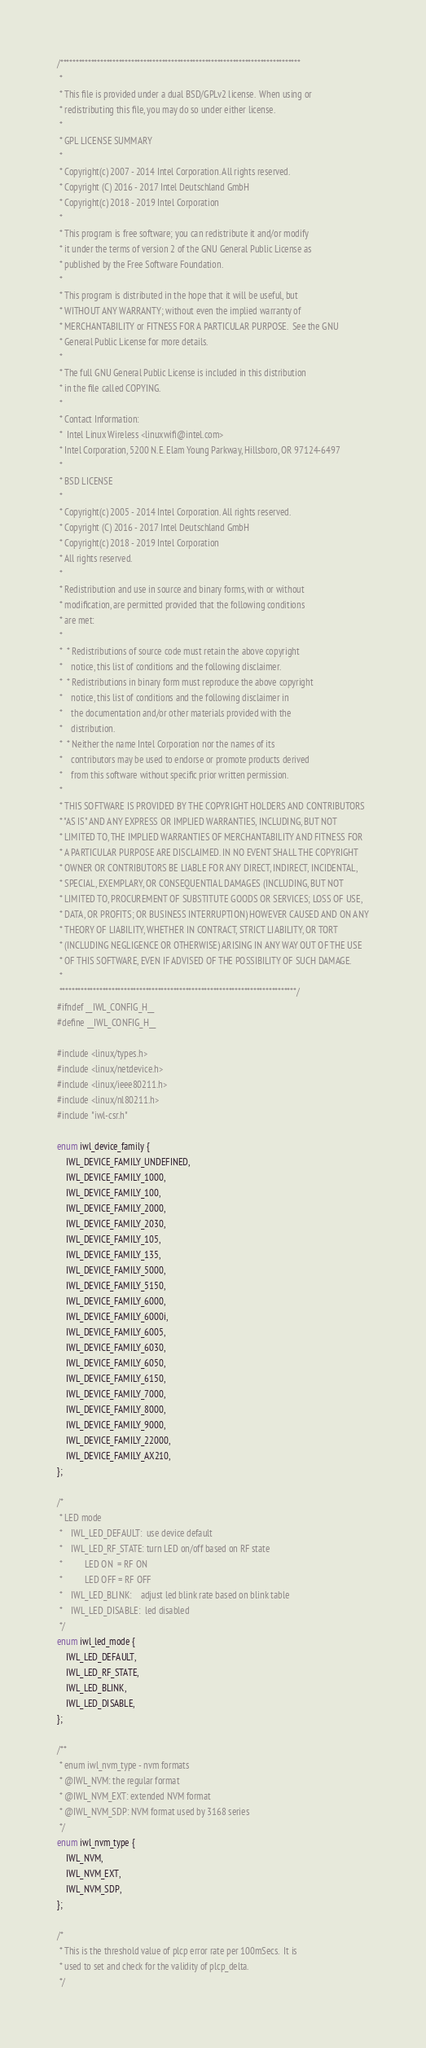Convert code to text. <code><loc_0><loc_0><loc_500><loc_500><_C_>/******************************************************************************
 *
 * This file is provided under a dual BSD/GPLv2 license.  When using or
 * redistributing this file, you may do so under either license.
 *
 * GPL LICENSE SUMMARY
 *
 * Copyright(c) 2007 - 2014 Intel Corporation. All rights reserved.
 * Copyright (C) 2016 - 2017 Intel Deutschland GmbH
 * Copyright(c) 2018 - 2019 Intel Corporation
 *
 * This program is free software; you can redistribute it and/or modify
 * it under the terms of version 2 of the GNU General Public License as
 * published by the Free Software Foundation.
 *
 * This program is distributed in the hope that it will be useful, but
 * WITHOUT ANY WARRANTY; without even the implied warranty of
 * MERCHANTABILITY or FITNESS FOR A PARTICULAR PURPOSE.  See the GNU
 * General Public License for more details.
 *
 * The full GNU General Public License is included in this distribution
 * in the file called COPYING.
 *
 * Contact Information:
 *  Intel Linux Wireless <linuxwifi@intel.com>
 * Intel Corporation, 5200 N.E. Elam Young Parkway, Hillsboro, OR 97124-6497
 *
 * BSD LICENSE
 *
 * Copyright(c) 2005 - 2014 Intel Corporation. All rights reserved.
 * Copyright (C) 2016 - 2017 Intel Deutschland GmbH
 * Copyright(c) 2018 - 2019 Intel Corporation
 * All rights reserved.
 *
 * Redistribution and use in source and binary forms, with or without
 * modification, are permitted provided that the following conditions
 * are met:
 *
 *  * Redistributions of source code must retain the above copyright
 *    notice, this list of conditions and the following disclaimer.
 *  * Redistributions in binary form must reproduce the above copyright
 *    notice, this list of conditions and the following disclaimer in
 *    the documentation and/or other materials provided with the
 *    distribution.
 *  * Neither the name Intel Corporation nor the names of its
 *    contributors may be used to endorse or promote products derived
 *    from this software without specific prior written permission.
 *
 * THIS SOFTWARE IS PROVIDED BY THE COPYRIGHT HOLDERS AND CONTRIBUTORS
 * "AS IS" AND ANY EXPRESS OR IMPLIED WARRANTIES, INCLUDING, BUT NOT
 * LIMITED TO, THE IMPLIED WARRANTIES OF MERCHANTABILITY AND FITNESS FOR
 * A PARTICULAR PURPOSE ARE DISCLAIMED. IN NO EVENT SHALL THE COPYRIGHT
 * OWNER OR CONTRIBUTORS BE LIABLE FOR ANY DIRECT, INDIRECT, INCIDENTAL,
 * SPECIAL, EXEMPLARY, OR CONSEQUENTIAL DAMAGES (INCLUDING, BUT NOT
 * LIMITED TO, PROCUREMENT OF SUBSTITUTE GOODS OR SERVICES; LOSS OF USE,
 * DATA, OR PROFITS; OR BUSINESS INTERRUPTION) HOWEVER CAUSED AND ON ANY
 * THEORY OF LIABILITY, WHETHER IN CONTRACT, STRICT LIABILITY, OR TORT
 * (INCLUDING NEGLIGENCE OR OTHERWISE) ARISING IN ANY WAY OUT OF THE USE
 * OF THIS SOFTWARE, EVEN IF ADVISED OF THE POSSIBILITY OF SUCH DAMAGE.
 *
 *****************************************************************************/
#ifndef __IWL_CONFIG_H__
#define __IWL_CONFIG_H__

#include <linux/types.h>
#include <linux/netdevice.h>
#include <linux/ieee80211.h>
#include <linux/nl80211.h>
#include "iwl-csr.h"

enum iwl_device_family {
	IWL_DEVICE_FAMILY_UNDEFINED,
	IWL_DEVICE_FAMILY_1000,
	IWL_DEVICE_FAMILY_100,
	IWL_DEVICE_FAMILY_2000,
	IWL_DEVICE_FAMILY_2030,
	IWL_DEVICE_FAMILY_105,
	IWL_DEVICE_FAMILY_135,
	IWL_DEVICE_FAMILY_5000,
	IWL_DEVICE_FAMILY_5150,
	IWL_DEVICE_FAMILY_6000,
	IWL_DEVICE_FAMILY_6000i,
	IWL_DEVICE_FAMILY_6005,
	IWL_DEVICE_FAMILY_6030,
	IWL_DEVICE_FAMILY_6050,
	IWL_DEVICE_FAMILY_6150,
	IWL_DEVICE_FAMILY_7000,
	IWL_DEVICE_FAMILY_8000,
	IWL_DEVICE_FAMILY_9000,
	IWL_DEVICE_FAMILY_22000,
	IWL_DEVICE_FAMILY_AX210,
};

/*
 * LED mode
 *    IWL_LED_DEFAULT:  use device default
 *    IWL_LED_RF_STATE: turn LED on/off based on RF state
 *			LED ON  = RF ON
 *			LED OFF = RF OFF
 *    IWL_LED_BLINK:    adjust led blink rate based on blink table
 *    IWL_LED_DISABLE:	led disabled
 */
enum iwl_led_mode {
	IWL_LED_DEFAULT,
	IWL_LED_RF_STATE,
	IWL_LED_BLINK,
	IWL_LED_DISABLE,
};

/**
 * enum iwl_nvm_type - nvm formats
 * @IWL_NVM: the regular format
 * @IWL_NVM_EXT: extended NVM format
 * @IWL_NVM_SDP: NVM format used by 3168 series
 */
enum iwl_nvm_type {
	IWL_NVM,
	IWL_NVM_EXT,
	IWL_NVM_SDP,
};

/*
 * This is the threshold value of plcp error rate per 100mSecs.  It is
 * used to set and check for the validity of plcp_delta.
 */</code> 